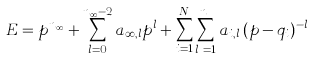<formula> <loc_0><loc_0><loc_500><loc_500>E = p ^ { n _ { \infty } } + \sum _ { l = 0 } ^ { n _ { \infty } - 2 } a _ { \infty , l } p ^ { l } + \sum _ { i = 1 } ^ { N } \sum _ { l _ { i } = 1 } ^ { n _ { i } } a _ { i , l _ { i } } ( p - q _ { i } ) ^ { - l _ { i } }</formula> 